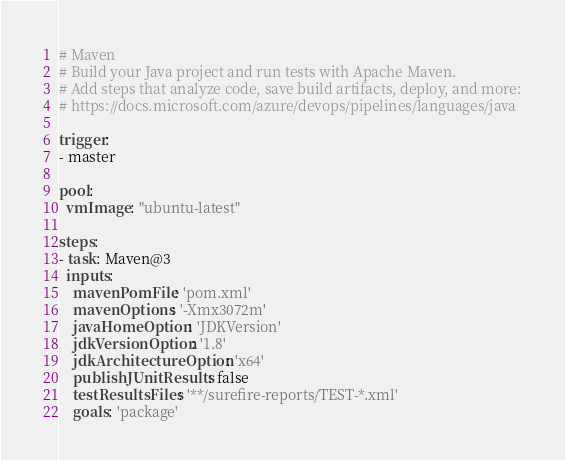<code> <loc_0><loc_0><loc_500><loc_500><_YAML_># Maven
# Build your Java project and run tests with Apache Maven.
# Add steps that analyze code, save build artifacts, deploy, and more:
# https://docs.microsoft.com/azure/devops/pipelines/languages/java

trigger:
- master

pool:
  vmImage: "ubuntu-latest"

steps:
- task: Maven@3
  inputs:
    mavenPomFile: 'pom.xml'
    mavenOptions: '-Xmx3072m'
    javaHomeOption: 'JDKVersion'
    jdkVersionOption: '1.8'
    jdkArchitectureOption: 'x64'
    publishJUnitResults: false
    testResultsFiles: '**/surefire-reports/TEST-*.xml'
    goals: 'package'
</code> 